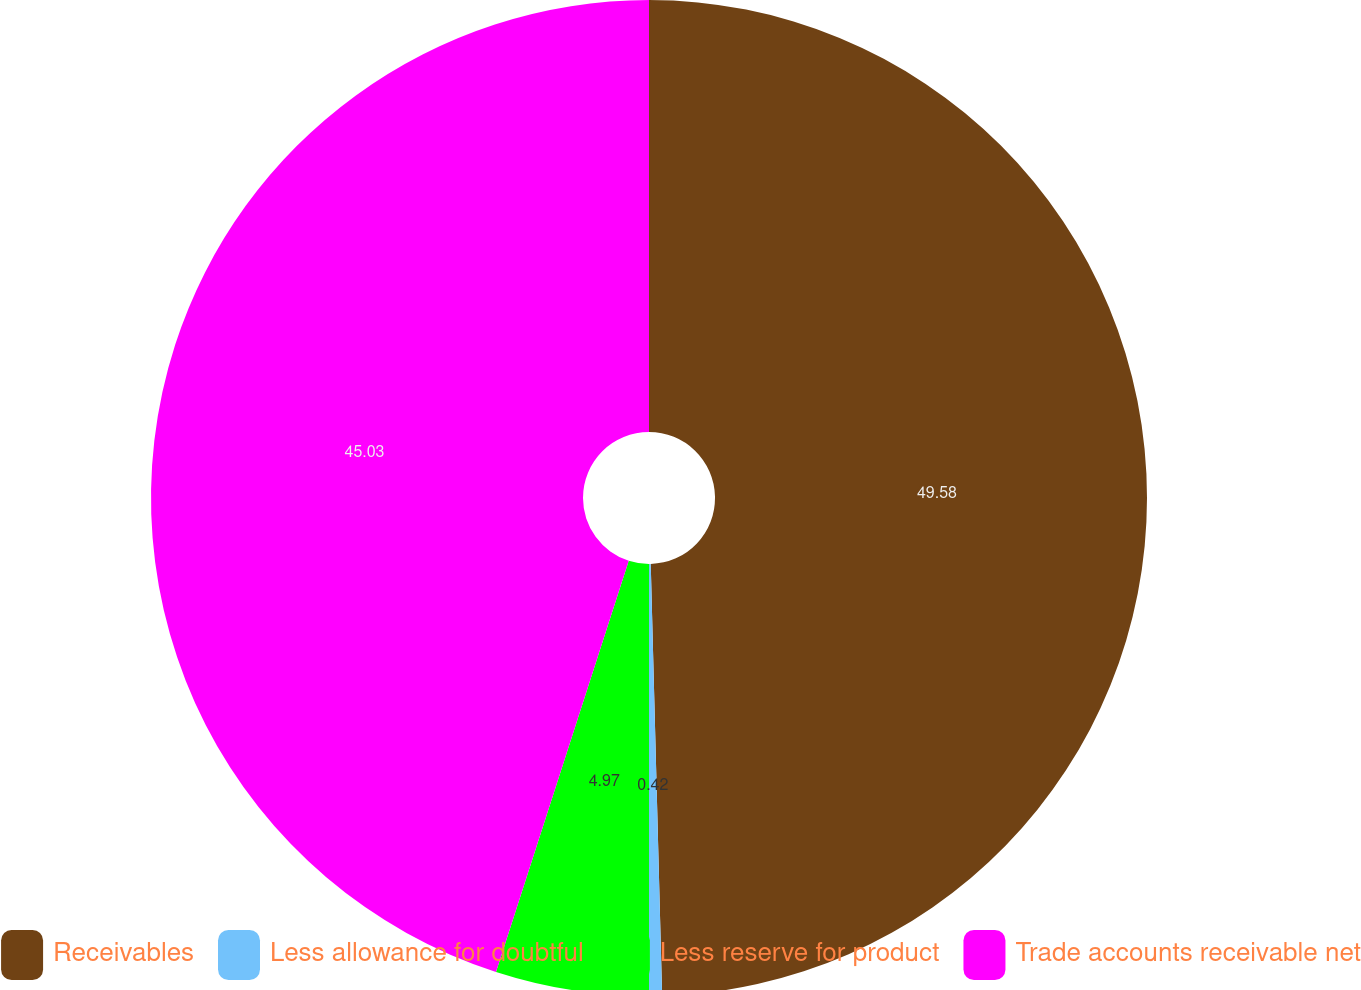Convert chart to OTSL. <chart><loc_0><loc_0><loc_500><loc_500><pie_chart><fcel>Receivables<fcel>Less allowance for doubtful<fcel>Less reserve for product<fcel>Trade accounts receivable net<nl><fcel>49.58%<fcel>0.42%<fcel>4.97%<fcel>45.03%<nl></chart> 